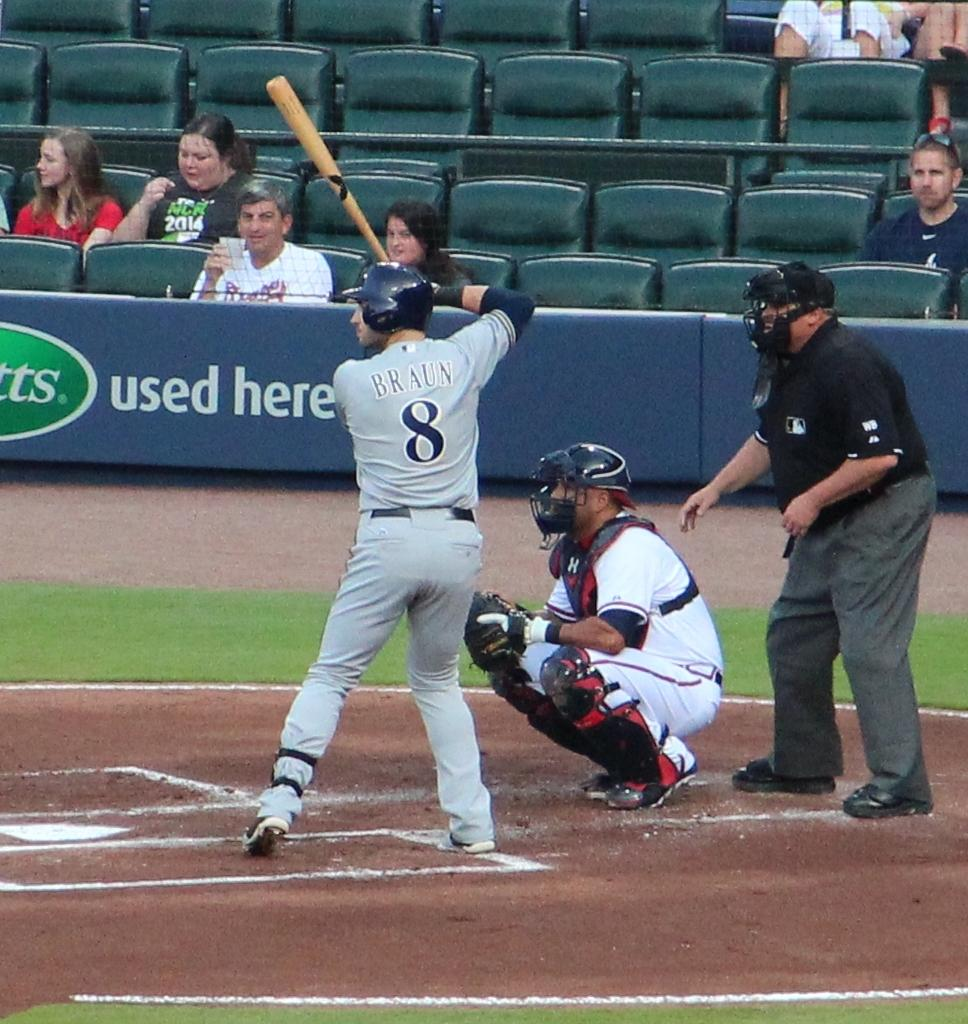<image>
Create a compact narrative representing the image presented. Baseball player wearing jersey number 8 about to bat the ball. 